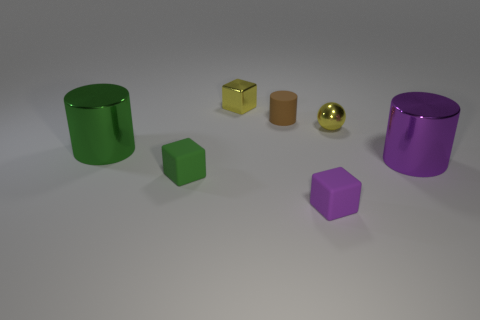There is a tiny yellow metallic object that is in front of the yellow metal object behind the tiny brown cylinder; are there any small things on the left side of it?
Your response must be concise. Yes. Is the purple metal cylinder the same size as the metallic cube?
Provide a succinct answer. No. There is a tiny matte block that is to the right of the tiny metallic thing behind the tiny rubber thing behind the yellow ball; what is its color?
Offer a very short reply. Purple. What number of tiny things are the same color as the tiny ball?
Offer a terse response. 1. How many tiny objects are either cyan cylinders or purple cylinders?
Your answer should be compact. 0. Is there another large green metallic thing of the same shape as the large green metallic thing?
Keep it short and to the point. No. Is the shape of the large purple metallic thing the same as the tiny purple matte object?
Your answer should be compact. No. What is the color of the small block that is right of the matte thing that is behind the big green cylinder?
Keep it short and to the point. Purple. What is the color of the shiny object that is the same size as the yellow cube?
Provide a short and direct response. Yellow. How many rubber things are either small purple cubes or large blue cylinders?
Offer a very short reply. 1. 